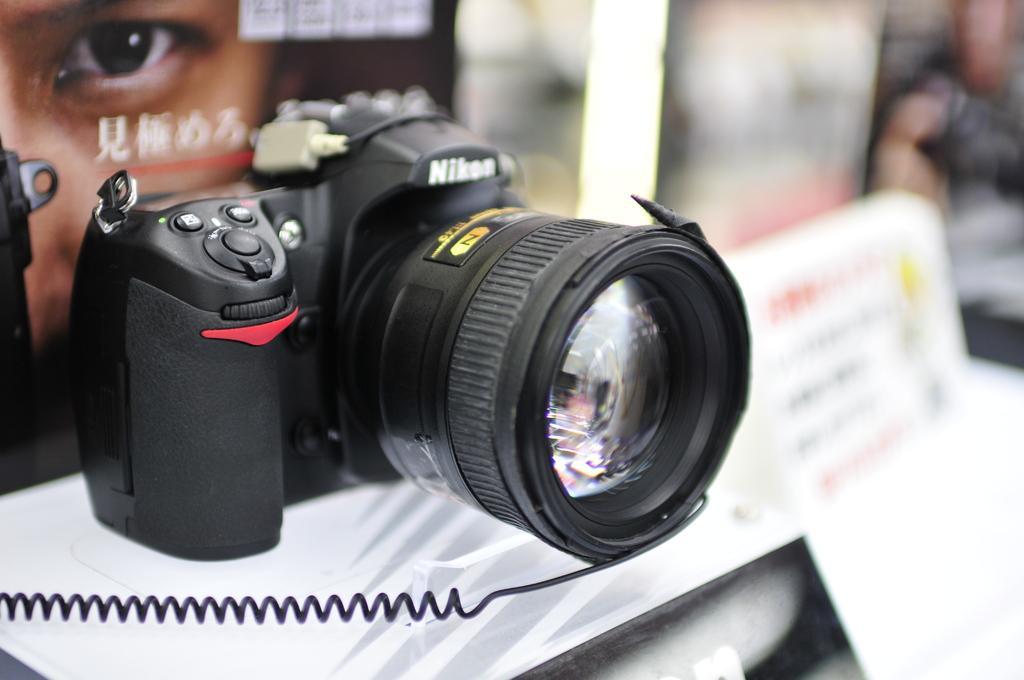Can you describe this image briefly? In this image, I can see a Nikon camera with the lens. This looks like a wire. On the left side of the image, that looks like a poster. I think this is a board. The background looks blurry. 